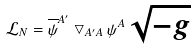<formula> <loc_0><loc_0><loc_500><loc_500>\mathcal { L } _ { N } = \overline { \psi } ^ { A ^ { \prime } } \bigtriangledown _ { A ^ { \prime } A } \psi ^ { A } \sqrt { - g }</formula> 